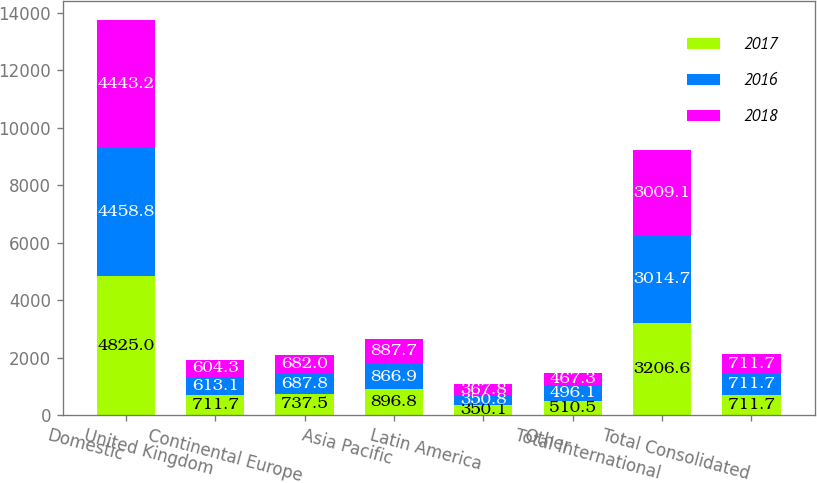Convert chart to OTSL. <chart><loc_0><loc_0><loc_500><loc_500><stacked_bar_chart><ecel><fcel>Domestic<fcel>United Kingdom<fcel>Continental Europe<fcel>Asia Pacific<fcel>Latin America<fcel>Other<fcel>Total International<fcel>Total Consolidated<nl><fcel>2017<fcel>4825<fcel>711.7<fcel>737.5<fcel>896.8<fcel>350.1<fcel>510.5<fcel>3206.6<fcel>711.7<nl><fcel>2016<fcel>4458.8<fcel>613.1<fcel>687.8<fcel>866.9<fcel>350.8<fcel>496.1<fcel>3014.7<fcel>711.7<nl><fcel>2018<fcel>4443.2<fcel>604.3<fcel>682<fcel>887.7<fcel>367.8<fcel>467.3<fcel>3009.1<fcel>711.7<nl></chart> 